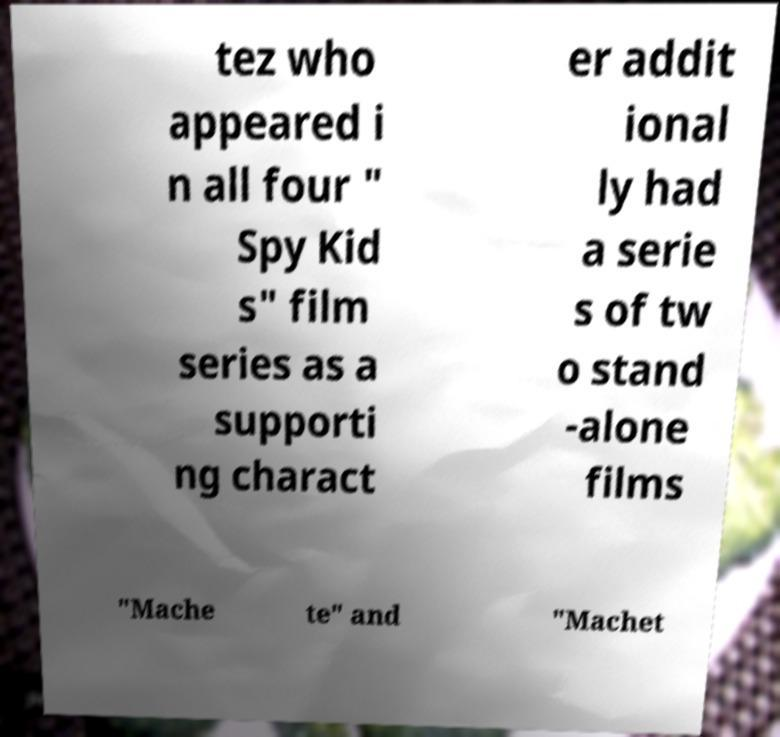Please identify and transcribe the text found in this image. tez who appeared i n all four " Spy Kid s" film series as a supporti ng charact er addit ional ly had a serie s of tw o stand -alone films "Mache te" and "Machet 